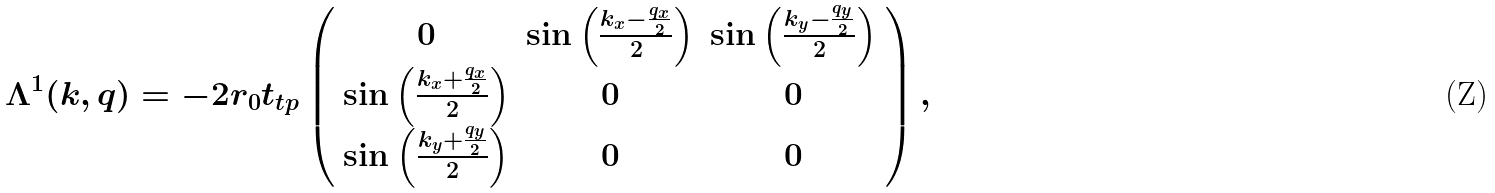<formula> <loc_0><loc_0><loc_500><loc_500>\Lambda ^ { 1 } ( k , q ) = - 2 r _ { 0 } t _ { t p } \left ( \begin{array} { c c c } 0 & \sin \left ( \frac { k _ { x } - \frac { q _ { x } } { 2 } } { 2 } \right ) & \sin \left ( \frac { k _ { y } - \frac { q _ { y } } { 2 } } { 2 } \right ) \\ \sin \left ( \frac { k _ { x } + \frac { q _ { x } } { 2 } } { 2 } \right ) & 0 & 0 \\ \sin \left ( \frac { k _ { y } + \frac { q _ { y } } { 2 } } { 2 } \right ) & 0 & 0 \end{array} \right ) ,</formula> 